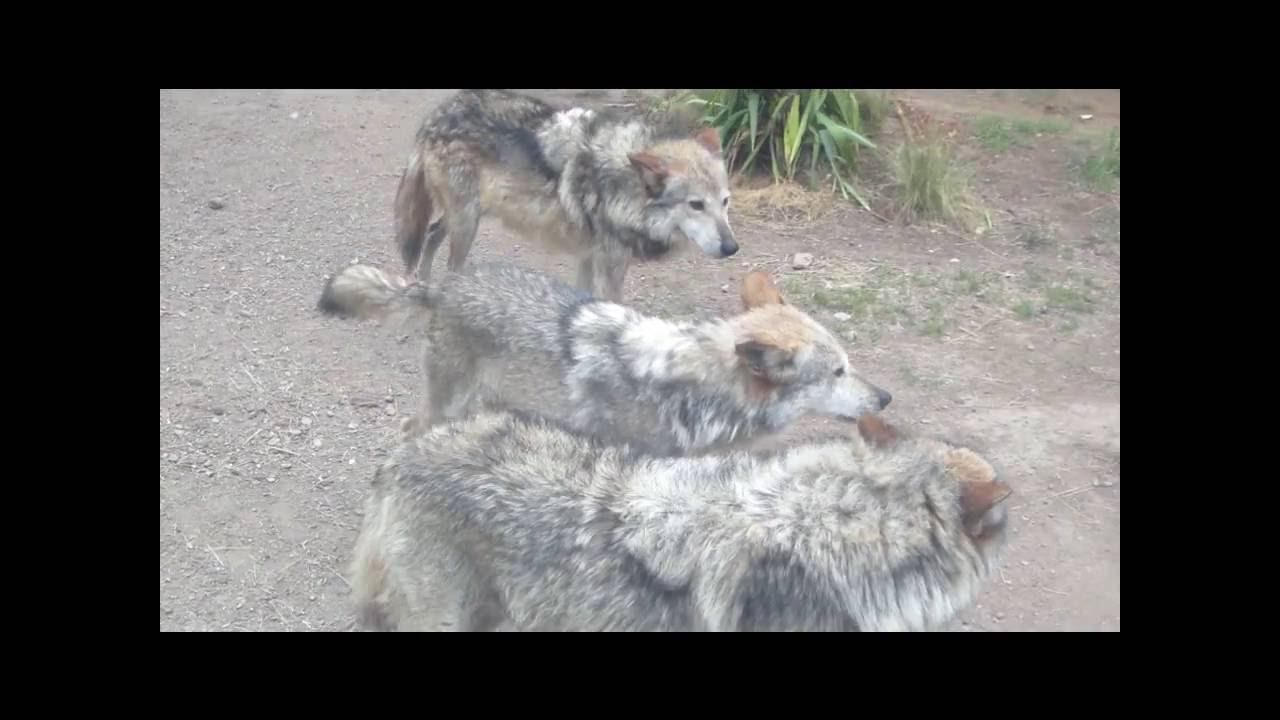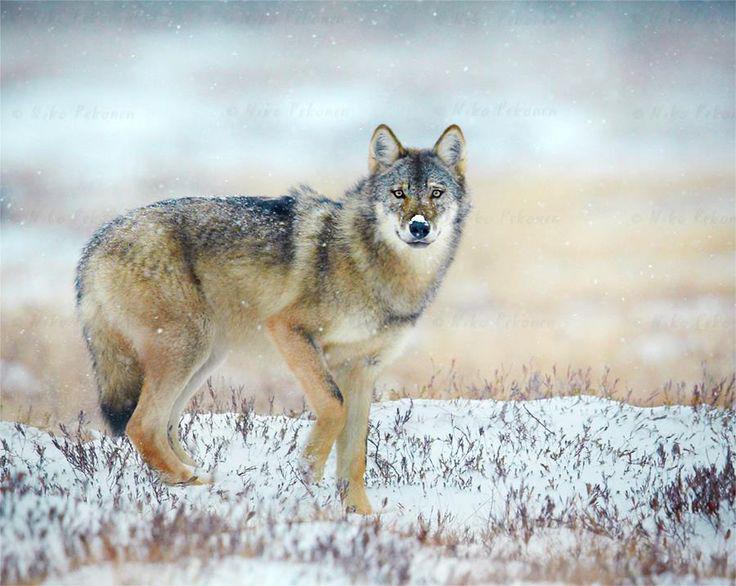The first image is the image on the left, the second image is the image on the right. Analyze the images presented: Is the assertion "The right image contains one forward turned wolf that is standing still and gazing ahead with a raised neck and head, and the left image contains one wolf walking leftward." valid? Answer yes or no. No. The first image is the image on the left, the second image is the image on the right. For the images displayed, is the sentence "in the left image there is a wold walking on snow covered ground with twigs sticking up through the snow" factually correct? Answer yes or no. No. 